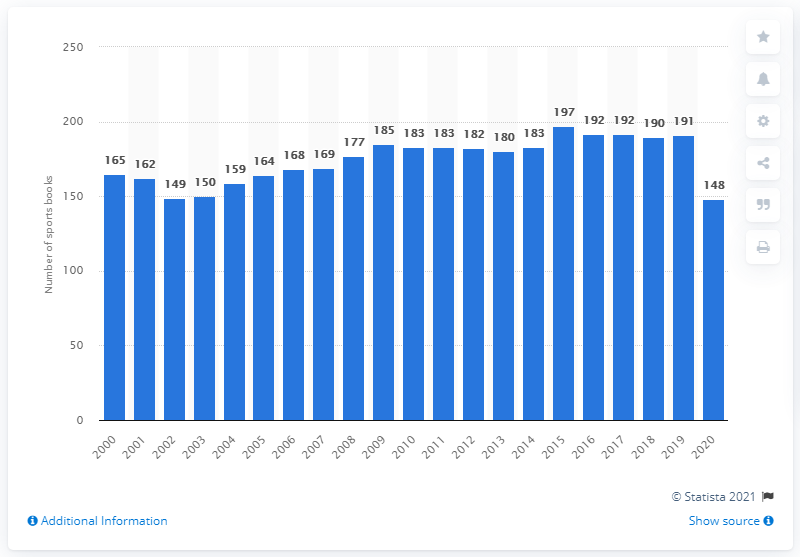Draw attention to some important aspects in this diagram. In 2015, there were 191 sports books in Nevada. In 2015, the number of sports books in Nevada peaked. 